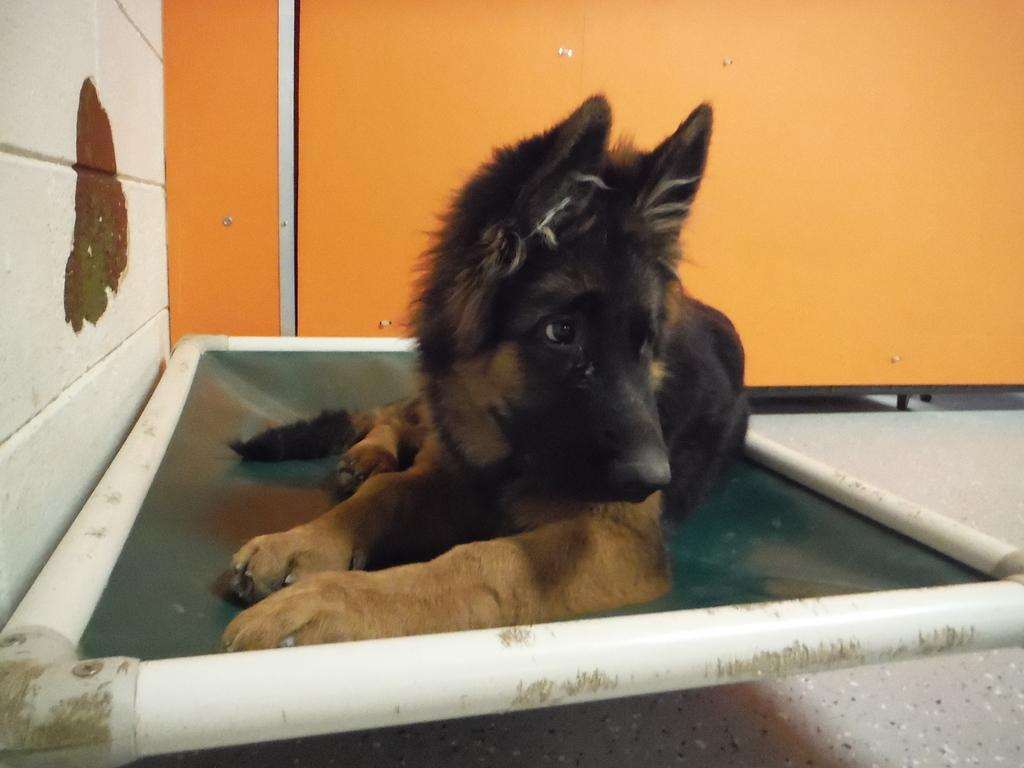What animal is present in the image? There is a dog in the image. Where is the dog located? The dog is in an object that resembles a tub. What can be seen in the background of the image? There is a wall visible in the image. What thoughts does the dog have about teaching zinc in the image? There is no indication of the dog's thoughts or teaching zinc in the image. 